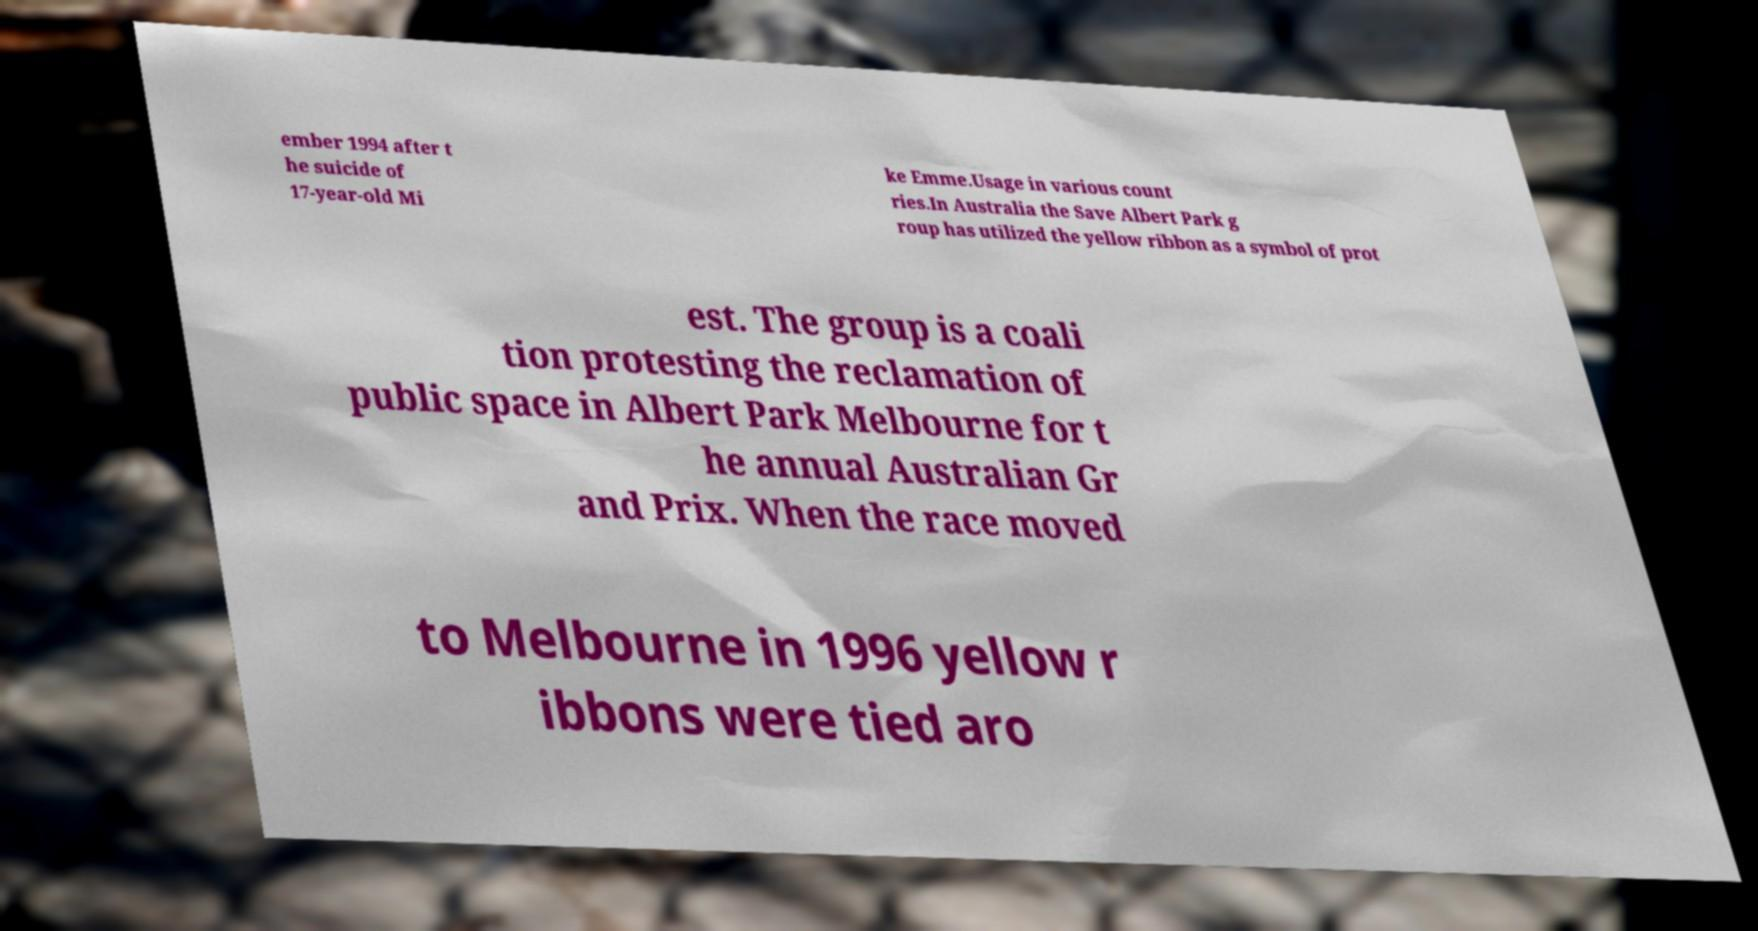There's text embedded in this image that I need extracted. Can you transcribe it verbatim? ember 1994 after t he suicide of 17-year-old Mi ke Emme.Usage in various count ries.In Australia the Save Albert Park g roup has utilized the yellow ribbon as a symbol of prot est. The group is a coali tion protesting the reclamation of public space in Albert Park Melbourne for t he annual Australian Gr and Prix. When the race moved to Melbourne in 1996 yellow r ibbons were tied aro 